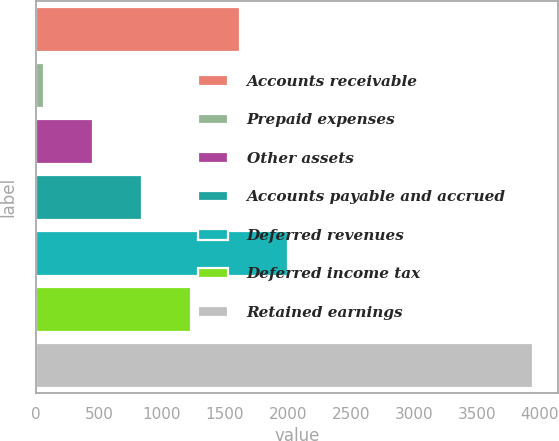<chart> <loc_0><loc_0><loc_500><loc_500><bar_chart><fcel>Accounts receivable<fcel>Prepaid expenses<fcel>Other assets<fcel>Accounts payable and accrued<fcel>Deferred revenues<fcel>Deferred income tax<fcel>Retained earnings<nl><fcel>1615.38<fcel>63.9<fcel>451.77<fcel>839.64<fcel>2003.25<fcel>1227.51<fcel>3942.6<nl></chart> 